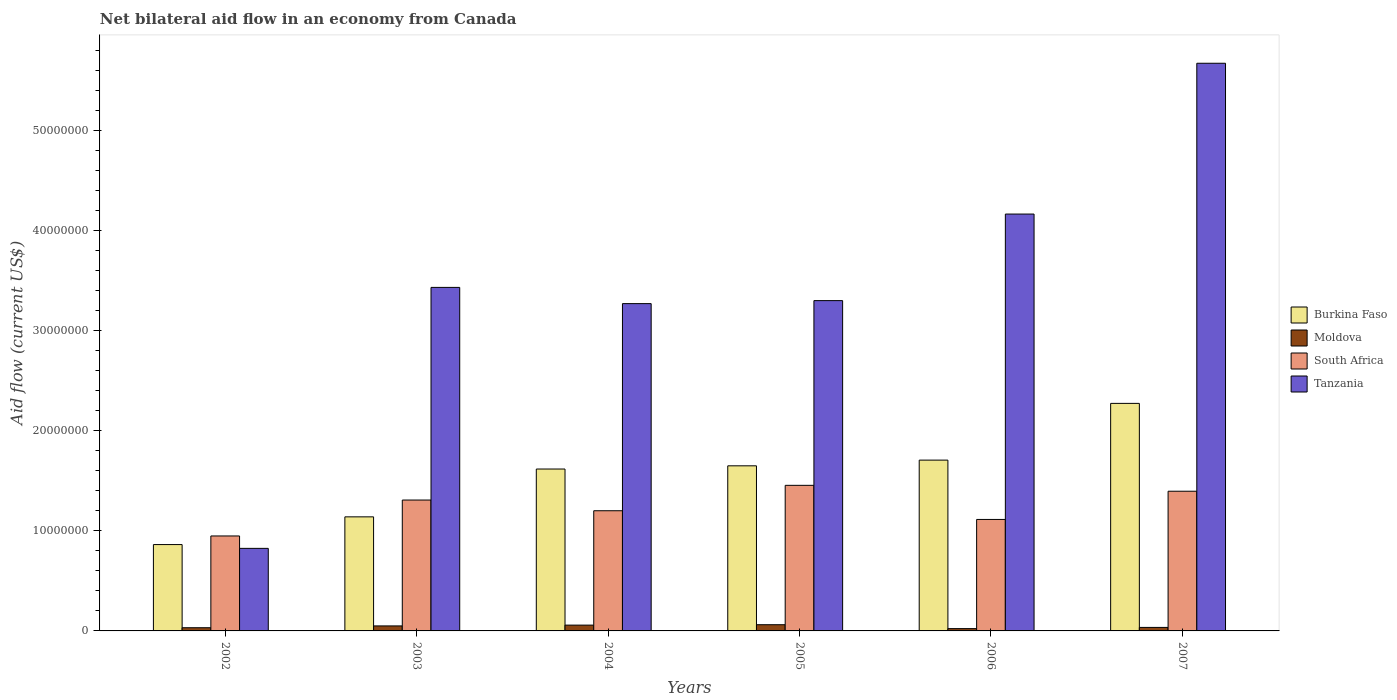How many groups of bars are there?
Provide a short and direct response. 6. Are the number of bars per tick equal to the number of legend labels?
Your answer should be compact. Yes. Are the number of bars on each tick of the X-axis equal?
Ensure brevity in your answer.  Yes. What is the net bilateral aid flow in Burkina Faso in 2004?
Give a very brief answer. 1.62e+07. Across all years, what is the maximum net bilateral aid flow in South Africa?
Provide a short and direct response. 1.46e+07. Across all years, what is the minimum net bilateral aid flow in South Africa?
Offer a terse response. 9.49e+06. In which year was the net bilateral aid flow in South Africa maximum?
Your answer should be compact. 2005. In which year was the net bilateral aid flow in Burkina Faso minimum?
Provide a short and direct response. 2002. What is the total net bilateral aid flow in South Africa in the graph?
Your answer should be very brief. 7.42e+07. What is the difference between the net bilateral aid flow in Burkina Faso in 2003 and that in 2005?
Your answer should be very brief. -5.10e+06. What is the difference between the net bilateral aid flow in Moldova in 2003 and the net bilateral aid flow in Burkina Faso in 2002?
Your answer should be very brief. -8.13e+06. What is the average net bilateral aid flow in Burkina Faso per year?
Provide a short and direct response. 1.54e+07. In the year 2004, what is the difference between the net bilateral aid flow in Burkina Faso and net bilateral aid flow in Tanzania?
Ensure brevity in your answer.  -1.65e+07. In how many years, is the net bilateral aid flow in Tanzania greater than 10000000 US$?
Make the answer very short. 5. What is the ratio of the net bilateral aid flow in Burkina Faso in 2002 to that in 2006?
Offer a very short reply. 0.51. What is the difference between the highest and the second highest net bilateral aid flow in South Africa?
Your response must be concise. 5.90e+05. What is the difference between the highest and the lowest net bilateral aid flow in Moldova?
Give a very brief answer. 3.90e+05. Is the sum of the net bilateral aid flow in South Africa in 2004 and 2005 greater than the maximum net bilateral aid flow in Tanzania across all years?
Provide a succinct answer. No. What does the 2nd bar from the left in 2003 represents?
Provide a succinct answer. Moldova. What does the 1st bar from the right in 2002 represents?
Give a very brief answer. Tanzania. Are all the bars in the graph horizontal?
Your answer should be very brief. No. How many years are there in the graph?
Offer a very short reply. 6. What is the difference between two consecutive major ticks on the Y-axis?
Your answer should be compact. 1.00e+07. Are the values on the major ticks of Y-axis written in scientific E-notation?
Provide a short and direct response. No. Does the graph contain any zero values?
Provide a short and direct response. No. How are the legend labels stacked?
Make the answer very short. Vertical. What is the title of the graph?
Offer a very short reply. Net bilateral aid flow in an economy from Canada. Does "Bhutan" appear as one of the legend labels in the graph?
Give a very brief answer. No. What is the label or title of the X-axis?
Provide a succinct answer. Years. What is the label or title of the Y-axis?
Ensure brevity in your answer.  Aid flow (current US$). What is the Aid flow (current US$) of Burkina Faso in 2002?
Offer a terse response. 8.63e+06. What is the Aid flow (current US$) in South Africa in 2002?
Your answer should be compact. 9.49e+06. What is the Aid flow (current US$) in Tanzania in 2002?
Your answer should be very brief. 8.25e+06. What is the Aid flow (current US$) of Burkina Faso in 2003?
Your answer should be very brief. 1.14e+07. What is the Aid flow (current US$) of South Africa in 2003?
Make the answer very short. 1.31e+07. What is the Aid flow (current US$) in Tanzania in 2003?
Your answer should be very brief. 3.43e+07. What is the Aid flow (current US$) in Burkina Faso in 2004?
Your response must be concise. 1.62e+07. What is the Aid flow (current US$) in Moldova in 2004?
Provide a short and direct response. 5.80e+05. What is the Aid flow (current US$) of South Africa in 2004?
Your response must be concise. 1.20e+07. What is the Aid flow (current US$) in Tanzania in 2004?
Make the answer very short. 3.27e+07. What is the Aid flow (current US$) in Burkina Faso in 2005?
Ensure brevity in your answer.  1.65e+07. What is the Aid flow (current US$) in Moldova in 2005?
Give a very brief answer. 6.20e+05. What is the Aid flow (current US$) of South Africa in 2005?
Keep it short and to the point. 1.46e+07. What is the Aid flow (current US$) of Tanzania in 2005?
Your response must be concise. 3.30e+07. What is the Aid flow (current US$) in Burkina Faso in 2006?
Your response must be concise. 1.71e+07. What is the Aid flow (current US$) of South Africa in 2006?
Your answer should be compact. 1.11e+07. What is the Aid flow (current US$) of Tanzania in 2006?
Give a very brief answer. 4.17e+07. What is the Aid flow (current US$) in Burkina Faso in 2007?
Your answer should be compact. 2.27e+07. What is the Aid flow (current US$) in Moldova in 2007?
Provide a short and direct response. 3.50e+05. What is the Aid flow (current US$) in South Africa in 2007?
Your answer should be very brief. 1.40e+07. What is the Aid flow (current US$) in Tanzania in 2007?
Give a very brief answer. 5.67e+07. Across all years, what is the maximum Aid flow (current US$) of Burkina Faso?
Provide a short and direct response. 2.27e+07. Across all years, what is the maximum Aid flow (current US$) in Moldova?
Make the answer very short. 6.20e+05. Across all years, what is the maximum Aid flow (current US$) in South Africa?
Your answer should be compact. 1.46e+07. Across all years, what is the maximum Aid flow (current US$) in Tanzania?
Your response must be concise. 5.67e+07. Across all years, what is the minimum Aid flow (current US$) in Burkina Faso?
Offer a very short reply. 8.63e+06. Across all years, what is the minimum Aid flow (current US$) in Moldova?
Your answer should be compact. 2.30e+05. Across all years, what is the minimum Aid flow (current US$) in South Africa?
Ensure brevity in your answer.  9.49e+06. Across all years, what is the minimum Aid flow (current US$) of Tanzania?
Give a very brief answer. 8.25e+06. What is the total Aid flow (current US$) in Burkina Faso in the graph?
Provide a succinct answer. 9.25e+07. What is the total Aid flow (current US$) in Moldova in the graph?
Provide a short and direct response. 2.60e+06. What is the total Aid flow (current US$) of South Africa in the graph?
Give a very brief answer. 7.42e+07. What is the total Aid flow (current US$) in Tanzania in the graph?
Keep it short and to the point. 2.07e+08. What is the difference between the Aid flow (current US$) of Burkina Faso in 2002 and that in 2003?
Your response must be concise. -2.77e+06. What is the difference between the Aid flow (current US$) of South Africa in 2002 and that in 2003?
Your answer should be compact. -3.59e+06. What is the difference between the Aid flow (current US$) in Tanzania in 2002 and that in 2003?
Offer a very short reply. -2.61e+07. What is the difference between the Aid flow (current US$) of Burkina Faso in 2002 and that in 2004?
Keep it short and to the point. -7.55e+06. What is the difference between the Aid flow (current US$) of Moldova in 2002 and that in 2004?
Ensure brevity in your answer.  -2.60e+05. What is the difference between the Aid flow (current US$) of South Africa in 2002 and that in 2004?
Your response must be concise. -2.52e+06. What is the difference between the Aid flow (current US$) of Tanzania in 2002 and that in 2004?
Make the answer very short. -2.45e+07. What is the difference between the Aid flow (current US$) in Burkina Faso in 2002 and that in 2005?
Your answer should be compact. -7.87e+06. What is the difference between the Aid flow (current US$) in South Africa in 2002 and that in 2005?
Your response must be concise. -5.06e+06. What is the difference between the Aid flow (current US$) of Tanzania in 2002 and that in 2005?
Make the answer very short. -2.48e+07. What is the difference between the Aid flow (current US$) in Burkina Faso in 2002 and that in 2006?
Give a very brief answer. -8.44e+06. What is the difference between the Aid flow (current US$) of South Africa in 2002 and that in 2006?
Make the answer very short. -1.65e+06. What is the difference between the Aid flow (current US$) in Tanzania in 2002 and that in 2006?
Your answer should be very brief. -3.34e+07. What is the difference between the Aid flow (current US$) in Burkina Faso in 2002 and that in 2007?
Provide a short and direct response. -1.41e+07. What is the difference between the Aid flow (current US$) of South Africa in 2002 and that in 2007?
Your response must be concise. -4.47e+06. What is the difference between the Aid flow (current US$) in Tanzania in 2002 and that in 2007?
Make the answer very short. -4.85e+07. What is the difference between the Aid flow (current US$) in Burkina Faso in 2003 and that in 2004?
Ensure brevity in your answer.  -4.78e+06. What is the difference between the Aid flow (current US$) in South Africa in 2003 and that in 2004?
Provide a succinct answer. 1.07e+06. What is the difference between the Aid flow (current US$) in Tanzania in 2003 and that in 2004?
Give a very brief answer. 1.62e+06. What is the difference between the Aid flow (current US$) in Burkina Faso in 2003 and that in 2005?
Offer a very short reply. -5.10e+06. What is the difference between the Aid flow (current US$) in South Africa in 2003 and that in 2005?
Provide a short and direct response. -1.47e+06. What is the difference between the Aid flow (current US$) in Tanzania in 2003 and that in 2005?
Ensure brevity in your answer.  1.32e+06. What is the difference between the Aid flow (current US$) in Burkina Faso in 2003 and that in 2006?
Your answer should be very brief. -5.67e+06. What is the difference between the Aid flow (current US$) in South Africa in 2003 and that in 2006?
Provide a succinct answer. 1.94e+06. What is the difference between the Aid flow (current US$) of Tanzania in 2003 and that in 2006?
Your response must be concise. -7.33e+06. What is the difference between the Aid flow (current US$) in Burkina Faso in 2003 and that in 2007?
Your response must be concise. -1.13e+07. What is the difference between the Aid flow (current US$) in South Africa in 2003 and that in 2007?
Provide a short and direct response. -8.80e+05. What is the difference between the Aid flow (current US$) in Tanzania in 2003 and that in 2007?
Your answer should be compact. -2.24e+07. What is the difference between the Aid flow (current US$) in Burkina Faso in 2004 and that in 2005?
Your response must be concise. -3.20e+05. What is the difference between the Aid flow (current US$) in South Africa in 2004 and that in 2005?
Your answer should be compact. -2.54e+06. What is the difference between the Aid flow (current US$) in Burkina Faso in 2004 and that in 2006?
Ensure brevity in your answer.  -8.90e+05. What is the difference between the Aid flow (current US$) in Moldova in 2004 and that in 2006?
Provide a short and direct response. 3.50e+05. What is the difference between the Aid flow (current US$) in South Africa in 2004 and that in 2006?
Your answer should be very brief. 8.70e+05. What is the difference between the Aid flow (current US$) in Tanzania in 2004 and that in 2006?
Give a very brief answer. -8.95e+06. What is the difference between the Aid flow (current US$) in Burkina Faso in 2004 and that in 2007?
Give a very brief answer. -6.56e+06. What is the difference between the Aid flow (current US$) of South Africa in 2004 and that in 2007?
Ensure brevity in your answer.  -1.95e+06. What is the difference between the Aid flow (current US$) in Tanzania in 2004 and that in 2007?
Your answer should be compact. -2.40e+07. What is the difference between the Aid flow (current US$) of Burkina Faso in 2005 and that in 2006?
Your answer should be compact. -5.70e+05. What is the difference between the Aid flow (current US$) of South Africa in 2005 and that in 2006?
Offer a terse response. 3.41e+06. What is the difference between the Aid flow (current US$) of Tanzania in 2005 and that in 2006?
Offer a terse response. -8.65e+06. What is the difference between the Aid flow (current US$) of Burkina Faso in 2005 and that in 2007?
Your response must be concise. -6.24e+06. What is the difference between the Aid flow (current US$) of Moldova in 2005 and that in 2007?
Your answer should be compact. 2.70e+05. What is the difference between the Aid flow (current US$) in South Africa in 2005 and that in 2007?
Make the answer very short. 5.90e+05. What is the difference between the Aid flow (current US$) of Tanzania in 2005 and that in 2007?
Offer a very short reply. -2.37e+07. What is the difference between the Aid flow (current US$) in Burkina Faso in 2006 and that in 2007?
Give a very brief answer. -5.67e+06. What is the difference between the Aid flow (current US$) of South Africa in 2006 and that in 2007?
Your response must be concise. -2.82e+06. What is the difference between the Aid flow (current US$) of Tanzania in 2006 and that in 2007?
Your answer should be compact. -1.51e+07. What is the difference between the Aid flow (current US$) in Burkina Faso in 2002 and the Aid flow (current US$) in Moldova in 2003?
Ensure brevity in your answer.  8.13e+06. What is the difference between the Aid flow (current US$) of Burkina Faso in 2002 and the Aid flow (current US$) of South Africa in 2003?
Keep it short and to the point. -4.45e+06. What is the difference between the Aid flow (current US$) in Burkina Faso in 2002 and the Aid flow (current US$) in Tanzania in 2003?
Offer a very short reply. -2.57e+07. What is the difference between the Aid flow (current US$) of Moldova in 2002 and the Aid flow (current US$) of South Africa in 2003?
Give a very brief answer. -1.28e+07. What is the difference between the Aid flow (current US$) in Moldova in 2002 and the Aid flow (current US$) in Tanzania in 2003?
Provide a short and direct response. -3.40e+07. What is the difference between the Aid flow (current US$) of South Africa in 2002 and the Aid flow (current US$) of Tanzania in 2003?
Offer a terse response. -2.48e+07. What is the difference between the Aid flow (current US$) in Burkina Faso in 2002 and the Aid flow (current US$) in Moldova in 2004?
Your answer should be compact. 8.05e+06. What is the difference between the Aid flow (current US$) of Burkina Faso in 2002 and the Aid flow (current US$) of South Africa in 2004?
Provide a short and direct response. -3.38e+06. What is the difference between the Aid flow (current US$) in Burkina Faso in 2002 and the Aid flow (current US$) in Tanzania in 2004?
Offer a terse response. -2.41e+07. What is the difference between the Aid flow (current US$) in Moldova in 2002 and the Aid flow (current US$) in South Africa in 2004?
Ensure brevity in your answer.  -1.17e+07. What is the difference between the Aid flow (current US$) of Moldova in 2002 and the Aid flow (current US$) of Tanzania in 2004?
Give a very brief answer. -3.24e+07. What is the difference between the Aid flow (current US$) of South Africa in 2002 and the Aid flow (current US$) of Tanzania in 2004?
Ensure brevity in your answer.  -2.32e+07. What is the difference between the Aid flow (current US$) of Burkina Faso in 2002 and the Aid flow (current US$) of Moldova in 2005?
Provide a succinct answer. 8.01e+06. What is the difference between the Aid flow (current US$) in Burkina Faso in 2002 and the Aid flow (current US$) in South Africa in 2005?
Give a very brief answer. -5.92e+06. What is the difference between the Aid flow (current US$) of Burkina Faso in 2002 and the Aid flow (current US$) of Tanzania in 2005?
Your response must be concise. -2.44e+07. What is the difference between the Aid flow (current US$) of Moldova in 2002 and the Aid flow (current US$) of South Africa in 2005?
Ensure brevity in your answer.  -1.42e+07. What is the difference between the Aid flow (current US$) of Moldova in 2002 and the Aid flow (current US$) of Tanzania in 2005?
Keep it short and to the point. -3.27e+07. What is the difference between the Aid flow (current US$) of South Africa in 2002 and the Aid flow (current US$) of Tanzania in 2005?
Your answer should be compact. -2.35e+07. What is the difference between the Aid flow (current US$) in Burkina Faso in 2002 and the Aid flow (current US$) in Moldova in 2006?
Give a very brief answer. 8.40e+06. What is the difference between the Aid flow (current US$) of Burkina Faso in 2002 and the Aid flow (current US$) of South Africa in 2006?
Provide a succinct answer. -2.51e+06. What is the difference between the Aid flow (current US$) in Burkina Faso in 2002 and the Aid flow (current US$) in Tanzania in 2006?
Provide a succinct answer. -3.30e+07. What is the difference between the Aid flow (current US$) in Moldova in 2002 and the Aid flow (current US$) in South Africa in 2006?
Provide a succinct answer. -1.08e+07. What is the difference between the Aid flow (current US$) in Moldova in 2002 and the Aid flow (current US$) in Tanzania in 2006?
Offer a very short reply. -4.13e+07. What is the difference between the Aid flow (current US$) of South Africa in 2002 and the Aid flow (current US$) of Tanzania in 2006?
Offer a very short reply. -3.22e+07. What is the difference between the Aid flow (current US$) in Burkina Faso in 2002 and the Aid flow (current US$) in Moldova in 2007?
Keep it short and to the point. 8.28e+06. What is the difference between the Aid flow (current US$) of Burkina Faso in 2002 and the Aid flow (current US$) of South Africa in 2007?
Give a very brief answer. -5.33e+06. What is the difference between the Aid flow (current US$) in Burkina Faso in 2002 and the Aid flow (current US$) in Tanzania in 2007?
Your response must be concise. -4.81e+07. What is the difference between the Aid flow (current US$) of Moldova in 2002 and the Aid flow (current US$) of South Africa in 2007?
Your answer should be very brief. -1.36e+07. What is the difference between the Aid flow (current US$) of Moldova in 2002 and the Aid flow (current US$) of Tanzania in 2007?
Your answer should be compact. -5.64e+07. What is the difference between the Aid flow (current US$) in South Africa in 2002 and the Aid flow (current US$) in Tanzania in 2007?
Make the answer very short. -4.72e+07. What is the difference between the Aid flow (current US$) of Burkina Faso in 2003 and the Aid flow (current US$) of Moldova in 2004?
Your answer should be compact. 1.08e+07. What is the difference between the Aid flow (current US$) of Burkina Faso in 2003 and the Aid flow (current US$) of South Africa in 2004?
Your response must be concise. -6.10e+05. What is the difference between the Aid flow (current US$) in Burkina Faso in 2003 and the Aid flow (current US$) in Tanzania in 2004?
Offer a terse response. -2.13e+07. What is the difference between the Aid flow (current US$) in Moldova in 2003 and the Aid flow (current US$) in South Africa in 2004?
Your response must be concise. -1.15e+07. What is the difference between the Aid flow (current US$) of Moldova in 2003 and the Aid flow (current US$) of Tanzania in 2004?
Your answer should be very brief. -3.22e+07. What is the difference between the Aid flow (current US$) in South Africa in 2003 and the Aid flow (current US$) in Tanzania in 2004?
Your answer should be very brief. -1.96e+07. What is the difference between the Aid flow (current US$) of Burkina Faso in 2003 and the Aid flow (current US$) of Moldova in 2005?
Offer a terse response. 1.08e+07. What is the difference between the Aid flow (current US$) of Burkina Faso in 2003 and the Aid flow (current US$) of South Africa in 2005?
Keep it short and to the point. -3.15e+06. What is the difference between the Aid flow (current US$) of Burkina Faso in 2003 and the Aid flow (current US$) of Tanzania in 2005?
Provide a short and direct response. -2.16e+07. What is the difference between the Aid flow (current US$) in Moldova in 2003 and the Aid flow (current US$) in South Africa in 2005?
Offer a very short reply. -1.40e+07. What is the difference between the Aid flow (current US$) in Moldova in 2003 and the Aid flow (current US$) in Tanzania in 2005?
Keep it short and to the point. -3.25e+07. What is the difference between the Aid flow (current US$) in South Africa in 2003 and the Aid flow (current US$) in Tanzania in 2005?
Provide a succinct answer. -1.99e+07. What is the difference between the Aid flow (current US$) in Burkina Faso in 2003 and the Aid flow (current US$) in Moldova in 2006?
Offer a very short reply. 1.12e+07. What is the difference between the Aid flow (current US$) in Burkina Faso in 2003 and the Aid flow (current US$) in Tanzania in 2006?
Give a very brief answer. -3.03e+07. What is the difference between the Aid flow (current US$) of Moldova in 2003 and the Aid flow (current US$) of South Africa in 2006?
Make the answer very short. -1.06e+07. What is the difference between the Aid flow (current US$) of Moldova in 2003 and the Aid flow (current US$) of Tanzania in 2006?
Make the answer very short. -4.12e+07. What is the difference between the Aid flow (current US$) in South Africa in 2003 and the Aid flow (current US$) in Tanzania in 2006?
Give a very brief answer. -2.86e+07. What is the difference between the Aid flow (current US$) of Burkina Faso in 2003 and the Aid flow (current US$) of Moldova in 2007?
Make the answer very short. 1.10e+07. What is the difference between the Aid flow (current US$) of Burkina Faso in 2003 and the Aid flow (current US$) of South Africa in 2007?
Keep it short and to the point. -2.56e+06. What is the difference between the Aid flow (current US$) of Burkina Faso in 2003 and the Aid flow (current US$) of Tanzania in 2007?
Make the answer very short. -4.53e+07. What is the difference between the Aid flow (current US$) of Moldova in 2003 and the Aid flow (current US$) of South Africa in 2007?
Keep it short and to the point. -1.35e+07. What is the difference between the Aid flow (current US$) in Moldova in 2003 and the Aid flow (current US$) in Tanzania in 2007?
Your answer should be compact. -5.62e+07. What is the difference between the Aid flow (current US$) in South Africa in 2003 and the Aid flow (current US$) in Tanzania in 2007?
Your response must be concise. -4.36e+07. What is the difference between the Aid flow (current US$) of Burkina Faso in 2004 and the Aid flow (current US$) of Moldova in 2005?
Your answer should be very brief. 1.56e+07. What is the difference between the Aid flow (current US$) of Burkina Faso in 2004 and the Aid flow (current US$) of South Africa in 2005?
Offer a terse response. 1.63e+06. What is the difference between the Aid flow (current US$) of Burkina Faso in 2004 and the Aid flow (current US$) of Tanzania in 2005?
Provide a succinct answer. -1.68e+07. What is the difference between the Aid flow (current US$) in Moldova in 2004 and the Aid flow (current US$) in South Africa in 2005?
Keep it short and to the point. -1.40e+07. What is the difference between the Aid flow (current US$) in Moldova in 2004 and the Aid flow (current US$) in Tanzania in 2005?
Keep it short and to the point. -3.24e+07. What is the difference between the Aid flow (current US$) in South Africa in 2004 and the Aid flow (current US$) in Tanzania in 2005?
Make the answer very short. -2.10e+07. What is the difference between the Aid flow (current US$) in Burkina Faso in 2004 and the Aid flow (current US$) in Moldova in 2006?
Make the answer very short. 1.60e+07. What is the difference between the Aid flow (current US$) in Burkina Faso in 2004 and the Aid flow (current US$) in South Africa in 2006?
Give a very brief answer. 5.04e+06. What is the difference between the Aid flow (current US$) in Burkina Faso in 2004 and the Aid flow (current US$) in Tanzania in 2006?
Provide a succinct answer. -2.55e+07. What is the difference between the Aid flow (current US$) of Moldova in 2004 and the Aid flow (current US$) of South Africa in 2006?
Give a very brief answer. -1.06e+07. What is the difference between the Aid flow (current US$) of Moldova in 2004 and the Aid flow (current US$) of Tanzania in 2006?
Keep it short and to the point. -4.11e+07. What is the difference between the Aid flow (current US$) of South Africa in 2004 and the Aid flow (current US$) of Tanzania in 2006?
Your response must be concise. -2.96e+07. What is the difference between the Aid flow (current US$) in Burkina Faso in 2004 and the Aid flow (current US$) in Moldova in 2007?
Your response must be concise. 1.58e+07. What is the difference between the Aid flow (current US$) of Burkina Faso in 2004 and the Aid flow (current US$) of South Africa in 2007?
Give a very brief answer. 2.22e+06. What is the difference between the Aid flow (current US$) in Burkina Faso in 2004 and the Aid flow (current US$) in Tanzania in 2007?
Provide a succinct answer. -4.06e+07. What is the difference between the Aid flow (current US$) of Moldova in 2004 and the Aid flow (current US$) of South Africa in 2007?
Offer a very short reply. -1.34e+07. What is the difference between the Aid flow (current US$) of Moldova in 2004 and the Aid flow (current US$) of Tanzania in 2007?
Give a very brief answer. -5.62e+07. What is the difference between the Aid flow (current US$) in South Africa in 2004 and the Aid flow (current US$) in Tanzania in 2007?
Your answer should be compact. -4.47e+07. What is the difference between the Aid flow (current US$) of Burkina Faso in 2005 and the Aid flow (current US$) of Moldova in 2006?
Offer a terse response. 1.63e+07. What is the difference between the Aid flow (current US$) in Burkina Faso in 2005 and the Aid flow (current US$) in South Africa in 2006?
Provide a succinct answer. 5.36e+06. What is the difference between the Aid flow (current US$) of Burkina Faso in 2005 and the Aid flow (current US$) of Tanzania in 2006?
Make the answer very short. -2.52e+07. What is the difference between the Aid flow (current US$) in Moldova in 2005 and the Aid flow (current US$) in South Africa in 2006?
Provide a succinct answer. -1.05e+07. What is the difference between the Aid flow (current US$) of Moldova in 2005 and the Aid flow (current US$) of Tanzania in 2006?
Ensure brevity in your answer.  -4.10e+07. What is the difference between the Aid flow (current US$) of South Africa in 2005 and the Aid flow (current US$) of Tanzania in 2006?
Offer a terse response. -2.71e+07. What is the difference between the Aid flow (current US$) of Burkina Faso in 2005 and the Aid flow (current US$) of Moldova in 2007?
Make the answer very short. 1.62e+07. What is the difference between the Aid flow (current US$) of Burkina Faso in 2005 and the Aid flow (current US$) of South Africa in 2007?
Ensure brevity in your answer.  2.54e+06. What is the difference between the Aid flow (current US$) of Burkina Faso in 2005 and the Aid flow (current US$) of Tanzania in 2007?
Provide a succinct answer. -4.02e+07. What is the difference between the Aid flow (current US$) in Moldova in 2005 and the Aid flow (current US$) in South Africa in 2007?
Your answer should be compact. -1.33e+07. What is the difference between the Aid flow (current US$) of Moldova in 2005 and the Aid flow (current US$) of Tanzania in 2007?
Your response must be concise. -5.61e+07. What is the difference between the Aid flow (current US$) of South Africa in 2005 and the Aid flow (current US$) of Tanzania in 2007?
Keep it short and to the point. -4.22e+07. What is the difference between the Aid flow (current US$) in Burkina Faso in 2006 and the Aid flow (current US$) in Moldova in 2007?
Ensure brevity in your answer.  1.67e+07. What is the difference between the Aid flow (current US$) in Burkina Faso in 2006 and the Aid flow (current US$) in South Africa in 2007?
Your answer should be compact. 3.11e+06. What is the difference between the Aid flow (current US$) of Burkina Faso in 2006 and the Aid flow (current US$) of Tanzania in 2007?
Ensure brevity in your answer.  -3.97e+07. What is the difference between the Aid flow (current US$) of Moldova in 2006 and the Aid flow (current US$) of South Africa in 2007?
Your answer should be compact. -1.37e+07. What is the difference between the Aid flow (current US$) of Moldova in 2006 and the Aid flow (current US$) of Tanzania in 2007?
Provide a succinct answer. -5.65e+07. What is the difference between the Aid flow (current US$) in South Africa in 2006 and the Aid flow (current US$) in Tanzania in 2007?
Ensure brevity in your answer.  -4.56e+07. What is the average Aid flow (current US$) in Burkina Faso per year?
Your answer should be compact. 1.54e+07. What is the average Aid flow (current US$) of Moldova per year?
Offer a very short reply. 4.33e+05. What is the average Aid flow (current US$) of South Africa per year?
Ensure brevity in your answer.  1.24e+07. What is the average Aid flow (current US$) in Tanzania per year?
Keep it short and to the point. 3.44e+07. In the year 2002, what is the difference between the Aid flow (current US$) in Burkina Faso and Aid flow (current US$) in Moldova?
Ensure brevity in your answer.  8.31e+06. In the year 2002, what is the difference between the Aid flow (current US$) in Burkina Faso and Aid flow (current US$) in South Africa?
Ensure brevity in your answer.  -8.60e+05. In the year 2002, what is the difference between the Aid flow (current US$) of Moldova and Aid flow (current US$) of South Africa?
Your response must be concise. -9.17e+06. In the year 2002, what is the difference between the Aid flow (current US$) in Moldova and Aid flow (current US$) in Tanzania?
Your response must be concise. -7.93e+06. In the year 2002, what is the difference between the Aid flow (current US$) in South Africa and Aid flow (current US$) in Tanzania?
Your response must be concise. 1.24e+06. In the year 2003, what is the difference between the Aid flow (current US$) in Burkina Faso and Aid flow (current US$) in Moldova?
Your answer should be very brief. 1.09e+07. In the year 2003, what is the difference between the Aid flow (current US$) of Burkina Faso and Aid flow (current US$) of South Africa?
Give a very brief answer. -1.68e+06. In the year 2003, what is the difference between the Aid flow (current US$) in Burkina Faso and Aid flow (current US$) in Tanzania?
Keep it short and to the point. -2.29e+07. In the year 2003, what is the difference between the Aid flow (current US$) in Moldova and Aid flow (current US$) in South Africa?
Provide a short and direct response. -1.26e+07. In the year 2003, what is the difference between the Aid flow (current US$) in Moldova and Aid flow (current US$) in Tanzania?
Provide a succinct answer. -3.38e+07. In the year 2003, what is the difference between the Aid flow (current US$) of South Africa and Aid flow (current US$) of Tanzania?
Ensure brevity in your answer.  -2.12e+07. In the year 2004, what is the difference between the Aid flow (current US$) in Burkina Faso and Aid flow (current US$) in Moldova?
Ensure brevity in your answer.  1.56e+07. In the year 2004, what is the difference between the Aid flow (current US$) of Burkina Faso and Aid flow (current US$) of South Africa?
Your answer should be compact. 4.17e+06. In the year 2004, what is the difference between the Aid flow (current US$) of Burkina Faso and Aid flow (current US$) of Tanzania?
Make the answer very short. -1.65e+07. In the year 2004, what is the difference between the Aid flow (current US$) of Moldova and Aid flow (current US$) of South Africa?
Give a very brief answer. -1.14e+07. In the year 2004, what is the difference between the Aid flow (current US$) in Moldova and Aid flow (current US$) in Tanzania?
Ensure brevity in your answer.  -3.21e+07. In the year 2004, what is the difference between the Aid flow (current US$) of South Africa and Aid flow (current US$) of Tanzania?
Provide a short and direct response. -2.07e+07. In the year 2005, what is the difference between the Aid flow (current US$) in Burkina Faso and Aid flow (current US$) in Moldova?
Keep it short and to the point. 1.59e+07. In the year 2005, what is the difference between the Aid flow (current US$) of Burkina Faso and Aid flow (current US$) of South Africa?
Your answer should be very brief. 1.95e+06. In the year 2005, what is the difference between the Aid flow (current US$) in Burkina Faso and Aid flow (current US$) in Tanzania?
Your answer should be very brief. -1.65e+07. In the year 2005, what is the difference between the Aid flow (current US$) of Moldova and Aid flow (current US$) of South Africa?
Offer a terse response. -1.39e+07. In the year 2005, what is the difference between the Aid flow (current US$) of Moldova and Aid flow (current US$) of Tanzania?
Provide a succinct answer. -3.24e+07. In the year 2005, what is the difference between the Aid flow (current US$) of South Africa and Aid flow (current US$) of Tanzania?
Provide a succinct answer. -1.85e+07. In the year 2006, what is the difference between the Aid flow (current US$) in Burkina Faso and Aid flow (current US$) in Moldova?
Your response must be concise. 1.68e+07. In the year 2006, what is the difference between the Aid flow (current US$) in Burkina Faso and Aid flow (current US$) in South Africa?
Your answer should be very brief. 5.93e+06. In the year 2006, what is the difference between the Aid flow (current US$) in Burkina Faso and Aid flow (current US$) in Tanzania?
Offer a very short reply. -2.46e+07. In the year 2006, what is the difference between the Aid flow (current US$) of Moldova and Aid flow (current US$) of South Africa?
Offer a very short reply. -1.09e+07. In the year 2006, what is the difference between the Aid flow (current US$) of Moldova and Aid flow (current US$) of Tanzania?
Offer a very short reply. -4.14e+07. In the year 2006, what is the difference between the Aid flow (current US$) in South Africa and Aid flow (current US$) in Tanzania?
Your answer should be very brief. -3.05e+07. In the year 2007, what is the difference between the Aid flow (current US$) of Burkina Faso and Aid flow (current US$) of Moldova?
Offer a very short reply. 2.24e+07. In the year 2007, what is the difference between the Aid flow (current US$) of Burkina Faso and Aid flow (current US$) of South Africa?
Provide a succinct answer. 8.78e+06. In the year 2007, what is the difference between the Aid flow (current US$) of Burkina Faso and Aid flow (current US$) of Tanzania?
Give a very brief answer. -3.40e+07. In the year 2007, what is the difference between the Aid flow (current US$) of Moldova and Aid flow (current US$) of South Africa?
Offer a very short reply. -1.36e+07. In the year 2007, what is the difference between the Aid flow (current US$) in Moldova and Aid flow (current US$) in Tanzania?
Your answer should be compact. -5.64e+07. In the year 2007, what is the difference between the Aid flow (current US$) in South Africa and Aid flow (current US$) in Tanzania?
Provide a short and direct response. -4.28e+07. What is the ratio of the Aid flow (current US$) in Burkina Faso in 2002 to that in 2003?
Provide a succinct answer. 0.76. What is the ratio of the Aid flow (current US$) of Moldova in 2002 to that in 2003?
Make the answer very short. 0.64. What is the ratio of the Aid flow (current US$) in South Africa in 2002 to that in 2003?
Give a very brief answer. 0.73. What is the ratio of the Aid flow (current US$) of Tanzania in 2002 to that in 2003?
Keep it short and to the point. 0.24. What is the ratio of the Aid flow (current US$) of Burkina Faso in 2002 to that in 2004?
Your answer should be very brief. 0.53. What is the ratio of the Aid flow (current US$) of Moldova in 2002 to that in 2004?
Keep it short and to the point. 0.55. What is the ratio of the Aid flow (current US$) in South Africa in 2002 to that in 2004?
Offer a terse response. 0.79. What is the ratio of the Aid flow (current US$) of Tanzania in 2002 to that in 2004?
Your response must be concise. 0.25. What is the ratio of the Aid flow (current US$) in Burkina Faso in 2002 to that in 2005?
Provide a short and direct response. 0.52. What is the ratio of the Aid flow (current US$) of Moldova in 2002 to that in 2005?
Your response must be concise. 0.52. What is the ratio of the Aid flow (current US$) in South Africa in 2002 to that in 2005?
Ensure brevity in your answer.  0.65. What is the ratio of the Aid flow (current US$) of Tanzania in 2002 to that in 2005?
Ensure brevity in your answer.  0.25. What is the ratio of the Aid flow (current US$) in Burkina Faso in 2002 to that in 2006?
Your answer should be compact. 0.51. What is the ratio of the Aid flow (current US$) of Moldova in 2002 to that in 2006?
Offer a terse response. 1.39. What is the ratio of the Aid flow (current US$) of South Africa in 2002 to that in 2006?
Make the answer very short. 0.85. What is the ratio of the Aid flow (current US$) in Tanzania in 2002 to that in 2006?
Provide a succinct answer. 0.2. What is the ratio of the Aid flow (current US$) of Burkina Faso in 2002 to that in 2007?
Provide a succinct answer. 0.38. What is the ratio of the Aid flow (current US$) in Moldova in 2002 to that in 2007?
Your response must be concise. 0.91. What is the ratio of the Aid flow (current US$) of South Africa in 2002 to that in 2007?
Ensure brevity in your answer.  0.68. What is the ratio of the Aid flow (current US$) in Tanzania in 2002 to that in 2007?
Provide a short and direct response. 0.15. What is the ratio of the Aid flow (current US$) of Burkina Faso in 2003 to that in 2004?
Offer a terse response. 0.7. What is the ratio of the Aid flow (current US$) in Moldova in 2003 to that in 2004?
Your answer should be very brief. 0.86. What is the ratio of the Aid flow (current US$) of South Africa in 2003 to that in 2004?
Your response must be concise. 1.09. What is the ratio of the Aid flow (current US$) in Tanzania in 2003 to that in 2004?
Keep it short and to the point. 1.05. What is the ratio of the Aid flow (current US$) of Burkina Faso in 2003 to that in 2005?
Give a very brief answer. 0.69. What is the ratio of the Aid flow (current US$) in Moldova in 2003 to that in 2005?
Your answer should be very brief. 0.81. What is the ratio of the Aid flow (current US$) in South Africa in 2003 to that in 2005?
Offer a terse response. 0.9. What is the ratio of the Aid flow (current US$) in Burkina Faso in 2003 to that in 2006?
Your response must be concise. 0.67. What is the ratio of the Aid flow (current US$) of Moldova in 2003 to that in 2006?
Provide a succinct answer. 2.17. What is the ratio of the Aid flow (current US$) in South Africa in 2003 to that in 2006?
Provide a succinct answer. 1.17. What is the ratio of the Aid flow (current US$) of Tanzania in 2003 to that in 2006?
Offer a terse response. 0.82. What is the ratio of the Aid flow (current US$) of Burkina Faso in 2003 to that in 2007?
Your answer should be very brief. 0.5. What is the ratio of the Aid flow (current US$) in Moldova in 2003 to that in 2007?
Ensure brevity in your answer.  1.43. What is the ratio of the Aid flow (current US$) in South Africa in 2003 to that in 2007?
Provide a short and direct response. 0.94. What is the ratio of the Aid flow (current US$) of Tanzania in 2003 to that in 2007?
Your answer should be very brief. 0.61. What is the ratio of the Aid flow (current US$) in Burkina Faso in 2004 to that in 2005?
Offer a very short reply. 0.98. What is the ratio of the Aid flow (current US$) in Moldova in 2004 to that in 2005?
Offer a very short reply. 0.94. What is the ratio of the Aid flow (current US$) of South Africa in 2004 to that in 2005?
Provide a succinct answer. 0.83. What is the ratio of the Aid flow (current US$) of Tanzania in 2004 to that in 2005?
Make the answer very short. 0.99. What is the ratio of the Aid flow (current US$) in Burkina Faso in 2004 to that in 2006?
Your response must be concise. 0.95. What is the ratio of the Aid flow (current US$) of Moldova in 2004 to that in 2006?
Your answer should be compact. 2.52. What is the ratio of the Aid flow (current US$) of South Africa in 2004 to that in 2006?
Make the answer very short. 1.08. What is the ratio of the Aid flow (current US$) in Tanzania in 2004 to that in 2006?
Ensure brevity in your answer.  0.79. What is the ratio of the Aid flow (current US$) in Burkina Faso in 2004 to that in 2007?
Make the answer very short. 0.71. What is the ratio of the Aid flow (current US$) in Moldova in 2004 to that in 2007?
Offer a very short reply. 1.66. What is the ratio of the Aid flow (current US$) of South Africa in 2004 to that in 2007?
Offer a very short reply. 0.86. What is the ratio of the Aid flow (current US$) of Tanzania in 2004 to that in 2007?
Your answer should be compact. 0.58. What is the ratio of the Aid flow (current US$) in Burkina Faso in 2005 to that in 2006?
Keep it short and to the point. 0.97. What is the ratio of the Aid flow (current US$) of Moldova in 2005 to that in 2006?
Ensure brevity in your answer.  2.7. What is the ratio of the Aid flow (current US$) of South Africa in 2005 to that in 2006?
Offer a terse response. 1.31. What is the ratio of the Aid flow (current US$) in Tanzania in 2005 to that in 2006?
Give a very brief answer. 0.79. What is the ratio of the Aid flow (current US$) in Burkina Faso in 2005 to that in 2007?
Ensure brevity in your answer.  0.73. What is the ratio of the Aid flow (current US$) in Moldova in 2005 to that in 2007?
Offer a terse response. 1.77. What is the ratio of the Aid flow (current US$) of South Africa in 2005 to that in 2007?
Make the answer very short. 1.04. What is the ratio of the Aid flow (current US$) of Tanzania in 2005 to that in 2007?
Give a very brief answer. 0.58. What is the ratio of the Aid flow (current US$) of Burkina Faso in 2006 to that in 2007?
Your answer should be compact. 0.75. What is the ratio of the Aid flow (current US$) of Moldova in 2006 to that in 2007?
Keep it short and to the point. 0.66. What is the ratio of the Aid flow (current US$) in South Africa in 2006 to that in 2007?
Provide a short and direct response. 0.8. What is the ratio of the Aid flow (current US$) in Tanzania in 2006 to that in 2007?
Provide a short and direct response. 0.73. What is the difference between the highest and the second highest Aid flow (current US$) in Burkina Faso?
Offer a terse response. 5.67e+06. What is the difference between the highest and the second highest Aid flow (current US$) in South Africa?
Give a very brief answer. 5.90e+05. What is the difference between the highest and the second highest Aid flow (current US$) of Tanzania?
Your response must be concise. 1.51e+07. What is the difference between the highest and the lowest Aid flow (current US$) of Burkina Faso?
Your answer should be very brief. 1.41e+07. What is the difference between the highest and the lowest Aid flow (current US$) in Moldova?
Your response must be concise. 3.90e+05. What is the difference between the highest and the lowest Aid flow (current US$) in South Africa?
Ensure brevity in your answer.  5.06e+06. What is the difference between the highest and the lowest Aid flow (current US$) of Tanzania?
Your answer should be compact. 4.85e+07. 